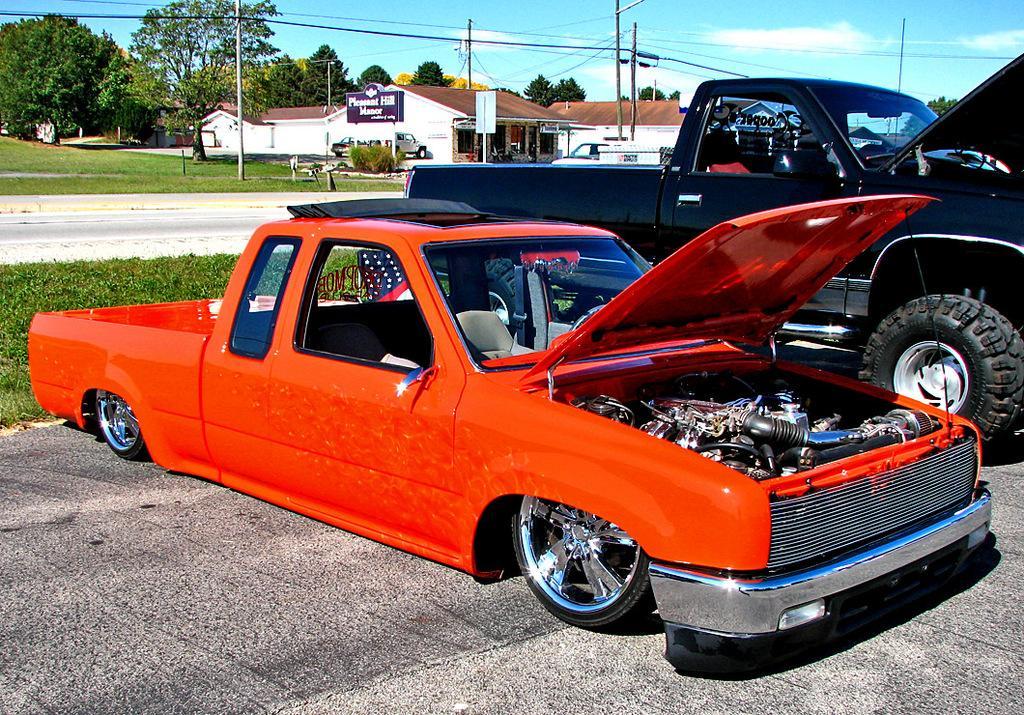Can you describe this image briefly? In this image there is the sky towards the top of the image, there are clouds in the sky, there are trees, there are buildings, there are boards, there is text on the board, there is a pole, there are wires, there is grass, there is road, there are two cars parked. 